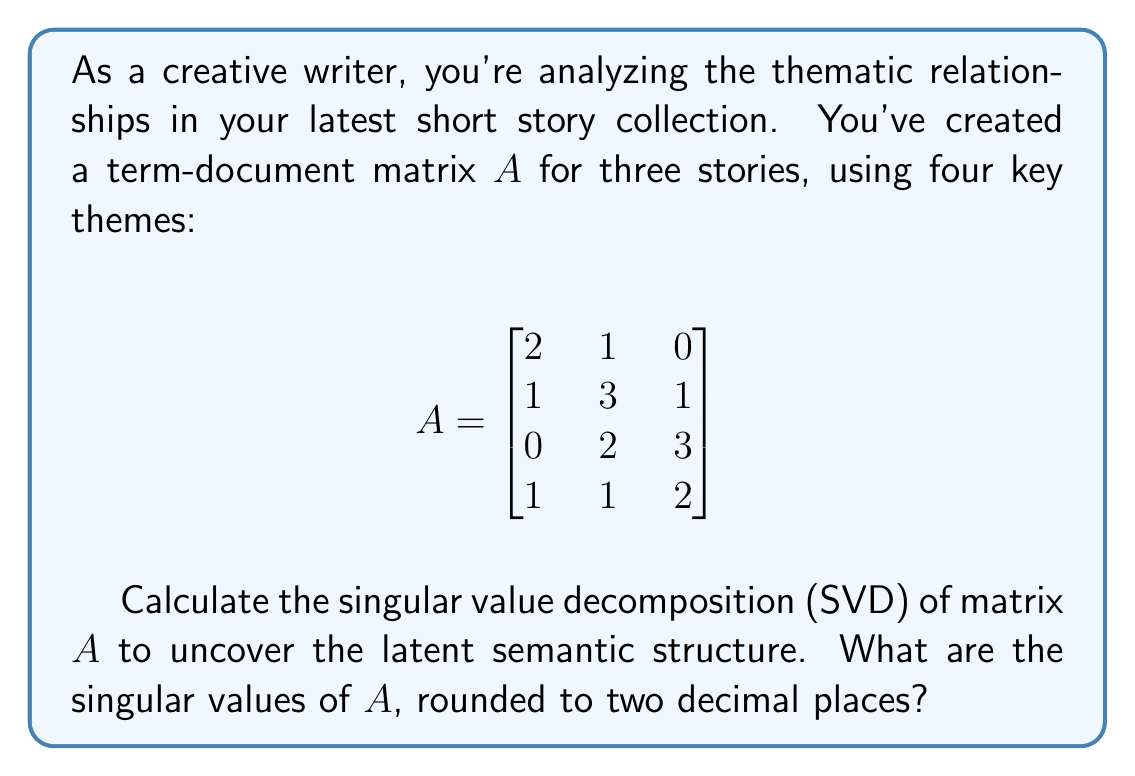Provide a solution to this math problem. To find the singular value decomposition of matrix $A$, we need to follow these steps:

1) First, calculate $A^TA$:

   $$A^TA = \begin{bmatrix}
   2 & 1 & 0 & 1 \\
   1 & 3 & 2 & 1 \\
   0 & 1 & 3 & 2
   \end{bmatrix} \begin{bmatrix}
   2 & 1 & 0 \\
   1 & 3 & 1 \\
   0 & 2 & 3 \\
   1 & 1 & 2
   \end{bmatrix} = \begin{bmatrix}
   6 & 7 & 5 \\
   7 & 15 & 13 \\
   5 & 13 & 18
   \end{bmatrix}$$

2) Find the eigenvalues of $A^TA$ by solving the characteristic equation:
   $det(A^TA - \lambda I) = 0$

3) This yields the characteristic polynomial:
   $-\lambda^3 + 39\lambda^2 - 270\lambda + 450 = 0$

4) Solving this equation gives us the eigenvalues:
   $\lambda_1 \approx 28.73, \lambda_2 \approx 9.70, \lambda_3 \approx 0.57$

5) The singular values are the square roots of these eigenvalues:
   $\sigma_1 = \sqrt{28.73} \approx 5.36$
   $\sigma_2 = \sqrt{9.70} \approx 3.11$
   $\sigma_3 = \sqrt{0.57} \approx 0.75$

These singular values, when rounded to two decimal places, give us the final answer.
Answer: 5.36, 3.11, 0.75 